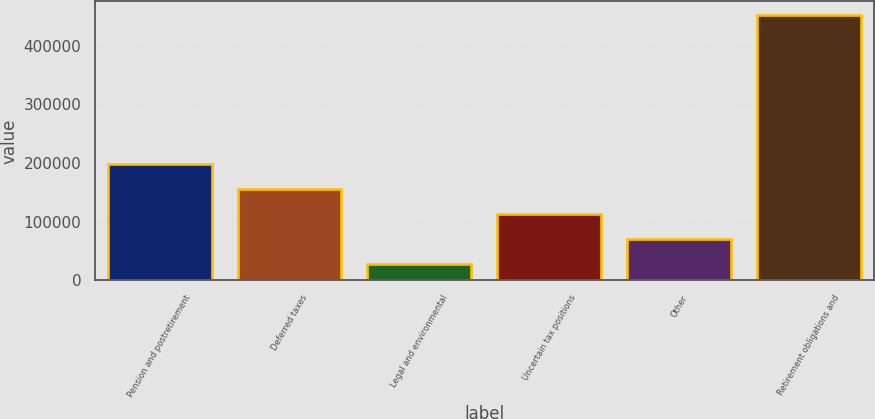Convert chart. <chart><loc_0><loc_0><loc_500><loc_500><bar_chart><fcel>Pension and postretirement<fcel>Deferred taxes<fcel>Legal and environmental<fcel>Uncertain tax positions<fcel>Other<fcel>Retirement obligations and<nl><fcel>197568<fcel>155078<fcel>27606<fcel>112587<fcel>70096.5<fcel>452511<nl></chart> 